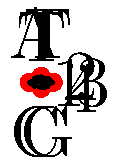In this directed graph representation of a plant DNA sequence, each vertex represents a nucleotide position, and each edge represents a transition between nucleotides. What is the DNA sequence represented by the longest path in this graph? To determine the DNA sequence represented by the longest path in this graph, we need to follow these steps:

1. Identify all possible paths in the graph:
   - 1 → 2 → 3 → 4 → 1
   - 1 → 2 → 3 → 4
   - 2 → 3 → 4 → 1
   - 3 → 4 → 1 → 2
   - 4 → 1 → 2 → 3
   - 1 → 3 → 4 → 1
   - 1 → 3 → 4
   - 3 → 4 → 1 → 3

2. Determine the longest path:
   The longest paths are those that visit all four vertices without repeating any vertex (except for the starting vertex if it completes a cycle). There are four such paths of equal length:
   - 1 → 2 → 3 → 4 → 1
   - 2 → 3 → 4 → 1 → 2
   - 3 → 4 → 1 → 2 → 3
   - 4 → 1 → 2 → 3 → 4

3. Choose one of these longest paths (e.g., 1 → 2 → 3 → 4 → 1) and read the nucleotides along the edges:
   - 1 → 2: A
   - 2 → 3: T
   - 3 → 4: G
   - 4 → 1: C

4. Combine the nucleotides to form the DNA sequence:
   The sequence is ATGC.

Thus, the DNA sequence represented by the longest path in this graph is ATGC.
Answer: ATGC 